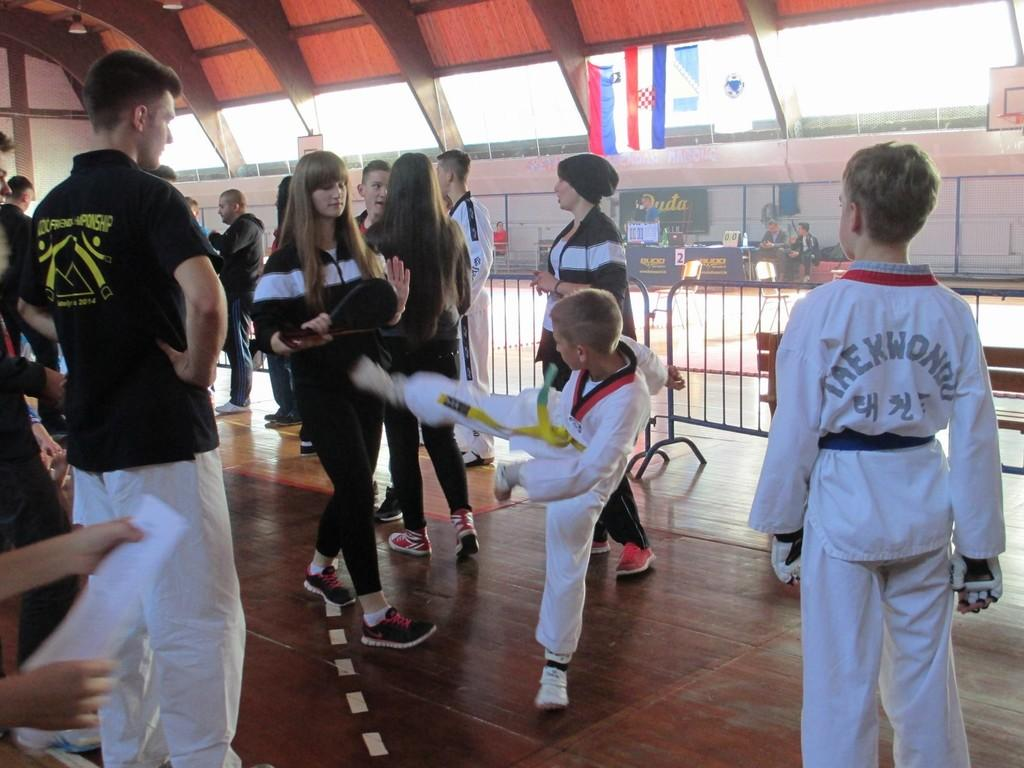Provide a one-sentence caption for the provided image. The kid in the white jersey has Taekwondo on the back. 